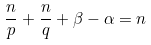<formula> <loc_0><loc_0><loc_500><loc_500>\frac { n } p + \frac { n } q + \beta - \alpha = n</formula> 